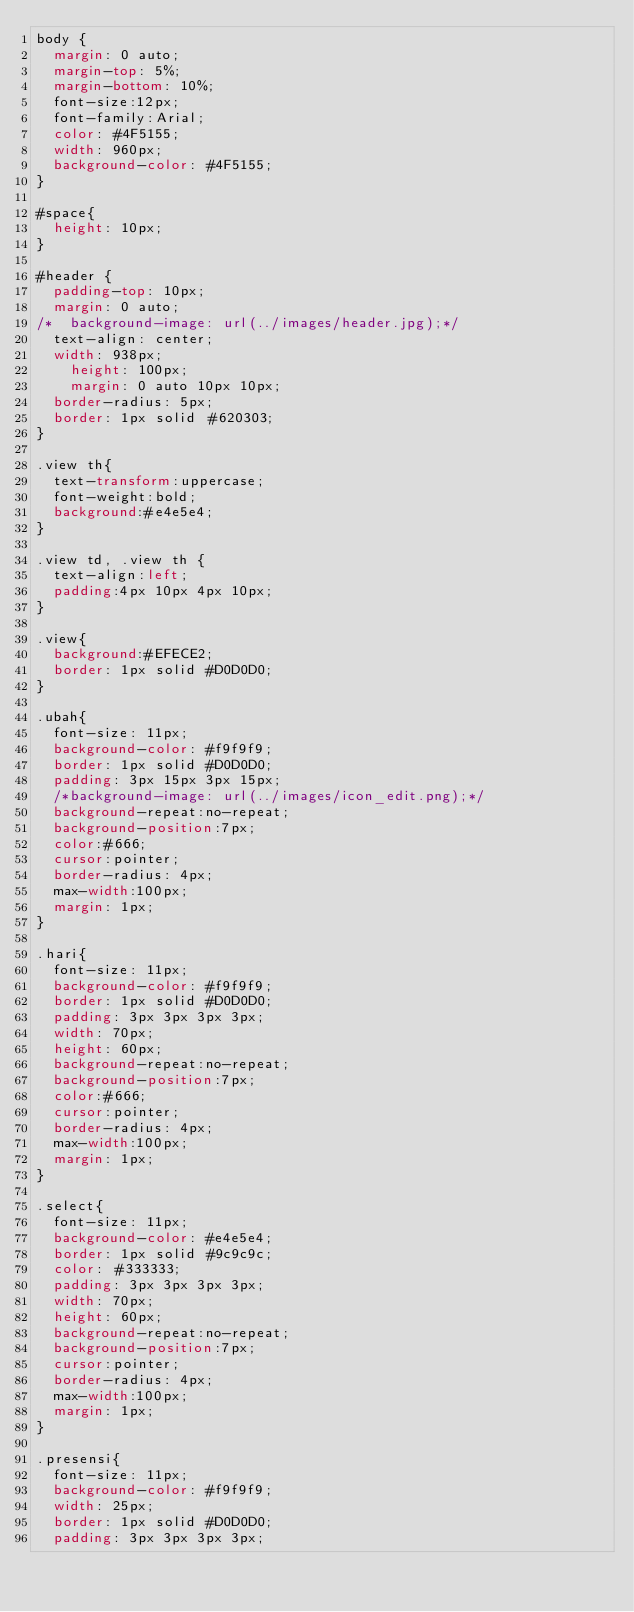<code> <loc_0><loc_0><loc_500><loc_500><_CSS_>body {
	margin: 0 auto;
	margin-top: 5%;
	margin-bottom: 10%;
	font-size:12px;
	font-family:Arial;
	color: #4F5155;
	width: 960px;
	background-color: #4F5155;
}

#space{
	height: 10px;
}

#header {
	padding-top: 10px;
	margin: 0 auto;
/*	background-image: url(../images/header.jpg);*/
	text-align: center;
	width: 938px;
  	height: 100px;
  	margin: 0 auto 10px 10px;
	border-radius: 5px;
	border: 1px solid #620303;
}

.view th{
	text-transform:uppercase;
	font-weight:bold;
	background:#e4e5e4;
}

.view td, .view th {
	text-align:left;
	padding:4px 10px 4px 10px;
}

.view{
	background:#EFECE2;
	border: 1px solid #D0D0D0;
}

.ubah{
	font-size: 11px;
	background-color: #f9f9f9;
	border: 1px solid #D0D0D0;
	padding: 3px 15px 3px 15px;
	/*background-image: url(../images/icon_edit.png);*/
	background-repeat:no-repeat;
	background-position:7px;
	color:#666;
	cursor:pointer; 
	border-radius: 4px;
	max-width:100px;
	margin: 1px;
}

.hari{
	font-size: 11px;
	background-color: #f9f9f9;
	border: 1px solid #D0D0D0;
	padding: 3px 3px 3px 3px;
	width: 70px;
	height: 60px;
	background-repeat:no-repeat;
	background-position:7px;
	color:#666;
	cursor:pointer; 
	border-radius: 4px;
	max-width:100px;
	margin: 1px;
}

.select{
	font-size: 11px;
	background-color: #e4e5e4;
	border: 1px solid #9c9c9c;
	color: #333333;
	padding: 3px 3px 3px 3px;
	width: 70px;
	height: 60px;
	background-repeat:no-repeat;
	background-position:7px;
	cursor:pointer; 
	border-radius: 4px;
	max-width:100px;
	margin: 1px;
}

.presensi{
	font-size: 11px;
	background-color: #f9f9f9;
	width: 25px;
	border: 1px solid #D0D0D0;
	padding: 3px 3px 3px 3px;	</code> 